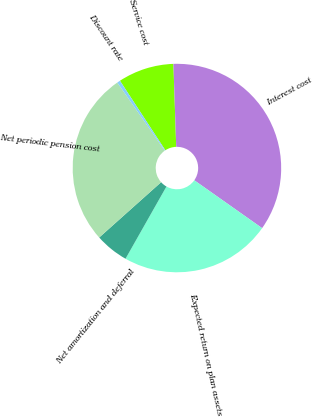Convert chart. <chart><loc_0><loc_0><loc_500><loc_500><pie_chart><fcel>Service cost<fcel>Interest cost<fcel>Expected return on plan assets<fcel>Net amortization and deferral<fcel>Net periodic pension cost<fcel>Discount rate<nl><fcel>8.67%<fcel>35.32%<fcel>23.43%<fcel>5.19%<fcel>26.91%<fcel>0.49%<nl></chart> 